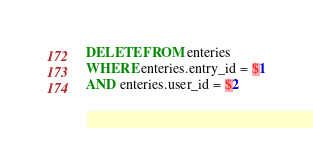<code> <loc_0><loc_0><loc_500><loc_500><_SQL_>DELETE FROM enteries
WHERE enteries.entry_id = $1
AND enteries.user_id = $2</code> 